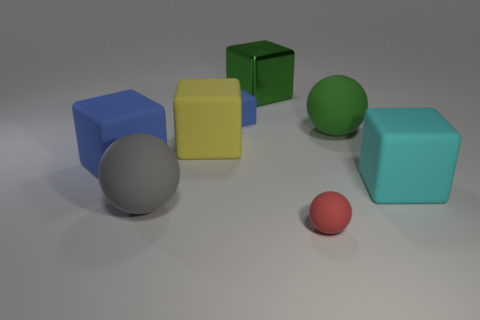What material is the tiny red object?
Your answer should be compact. Rubber. There is a green thing that is in front of the blue matte thing behind the blue thing on the left side of the yellow object; what is it made of?
Make the answer very short. Rubber. Are there any other things that have the same shape as the red object?
Offer a terse response. Yes. What is the color of the small thing that is the same shape as the large metallic object?
Provide a succinct answer. Blue. There is a large thing that is in front of the cyan block; is it the same color as the cube that is behind the tiny block?
Provide a succinct answer. No. Is the number of red matte objects behind the big green metallic thing greater than the number of large blue blocks?
Your answer should be very brief. No. What number of other objects are the same size as the metallic thing?
Give a very brief answer. 5. How many blocks are behind the large yellow block and on the right side of the small red ball?
Offer a very short reply. 0. Do the large sphere that is in front of the big yellow rubber block and the big cyan object have the same material?
Offer a terse response. Yes. There is a small rubber thing that is on the left side of the small rubber object that is in front of the cube right of the big metal thing; what shape is it?
Give a very brief answer. Cube. 